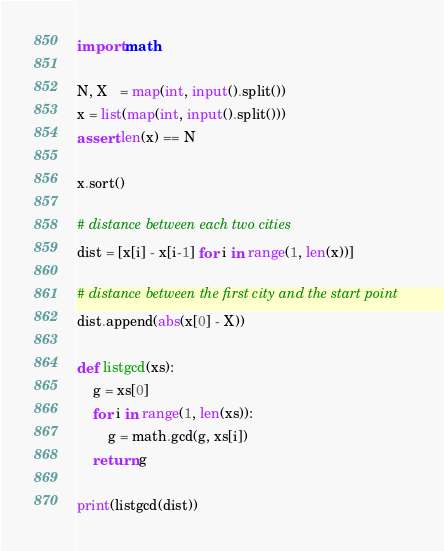<code> <loc_0><loc_0><loc_500><loc_500><_Python_>import math

N, X   = map(int, input().split())
x = list(map(int, input().split()))
assert len(x) == N

x.sort()

# distance between each two cities
dist = [x[i] - x[i-1] for i in range(1, len(x))]

# distance between the first city and the start point
dist.append(abs(x[0] - X))

def listgcd(xs):
    g = xs[0]
    for i in range(1, len(xs)):
        g = math.gcd(g, xs[i])
    return g

print(listgcd(dist))
</code> 